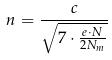<formula> <loc_0><loc_0><loc_500><loc_500>n = \frac { c } { \sqrt { 7 \cdot \frac { e \cdot N } { 2 N _ { m } } } }</formula> 